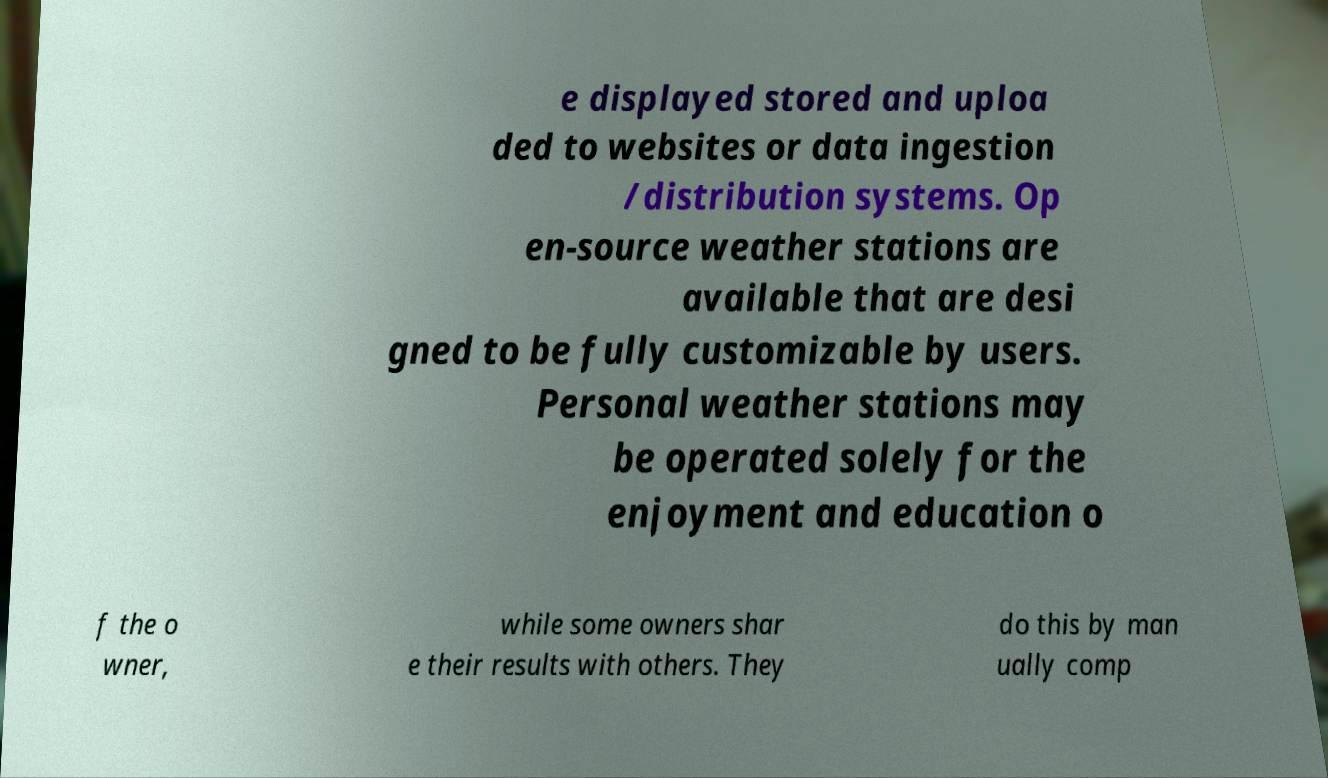I need the written content from this picture converted into text. Can you do that? e displayed stored and uploa ded to websites or data ingestion /distribution systems. Op en-source weather stations are available that are desi gned to be fully customizable by users. Personal weather stations may be operated solely for the enjoyment and education o f the o wner, while some owners shar e their results with others. They do this by man ually comp 